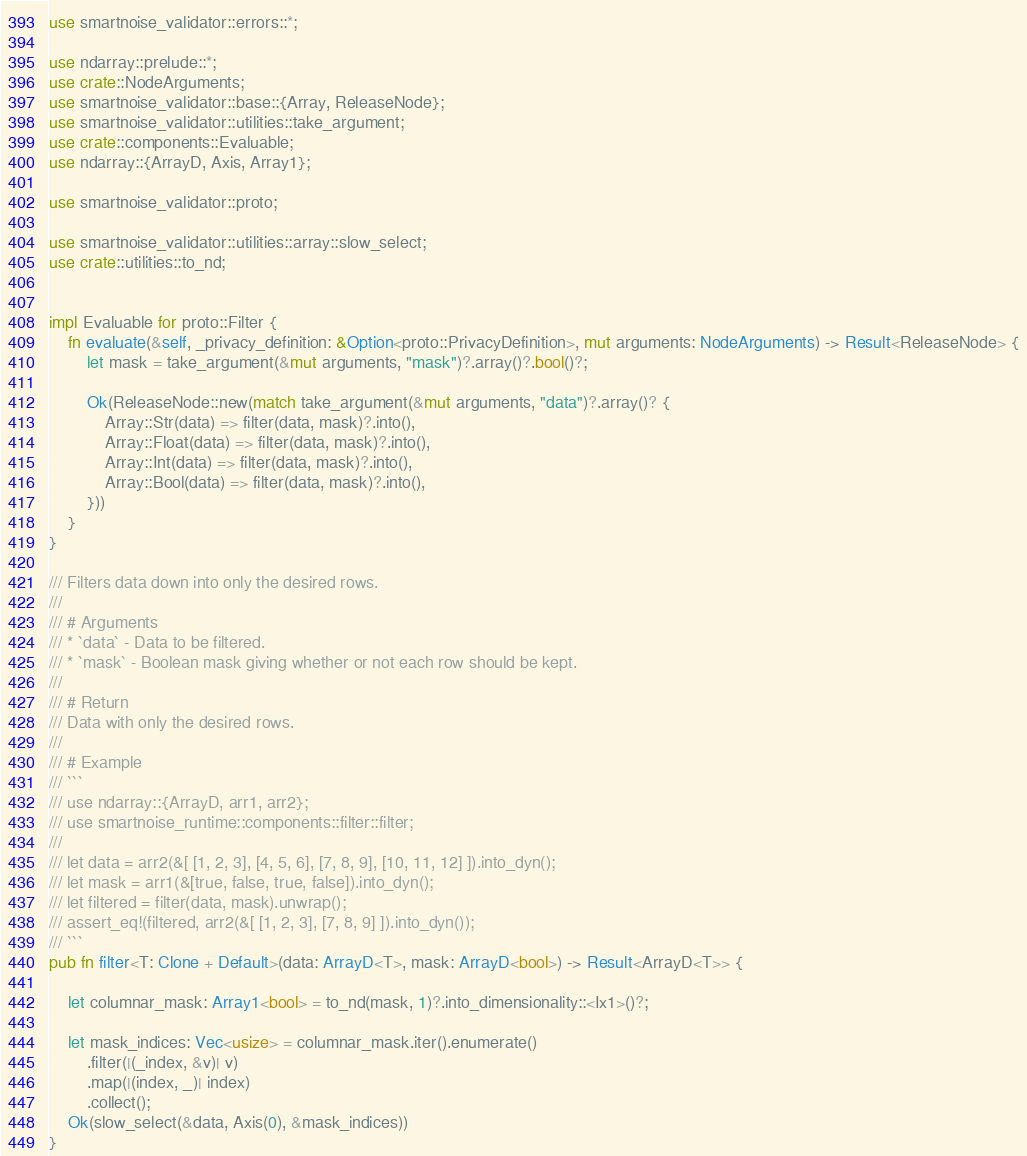Convert code to text. <code><loc_0><loc_0><loc_500><loc_500><_Rust_>use smartnoise_validator::errors::*;

use ndarray::prelude::*;
use crate::NodeArguments;
use smartnoise_validator::base::{Array, ReleaseNode};
use smartnoise_validator::utilities::take_argument;
use crate::components::Evaluable;
use ndarray::{ArrayD, Axis, Array1};

use smartnoise_validator::proto;

use smartnoise_validator::utilities::array::slow_select;
use crate::utilities::to_nd;


impl Evaluable for proto::Filter {
    fn evaluate(&self, _privacy_definition: &Option<proto::PrivacyDefinition>, mut arguments: NodeArguments) -> Result<ReleaseNode> {
        let mask = take_argument(&mut arguments, "mask")?.array()?.bool()?;

        Ok(ReleaseNode::new(match take_argument(&mut arguments, "data")?.array()? {
            Array::Str(data) => filter(data, mask)?.into(),
            Array::Float(data) => filter(data, mask)?.into(),
            Array::Int(data) => filter(data, mask)?.into(),
            Array::Bool(data) => filter(data, mask)?.into(),
        }))
    }
}

/// Filters data down into only the desired rows.
///
/// # Arguments
/// * `data` - Data to be filtered.
/// * `mask` - Boolean mask giving whether or not each row should be kept.
///
/// # Return
/// Data with only the desired rows.
///
/// # Example
/// ```
/// use ndarray::{ArrayD, arr1, arr2};
/// use smartnoise_runtime::components::filter::filter;
///
/// let data = arr2(&[ [1, 2, 3], [4, 5, 6], [7, 8, 9], [10, 11, 12] ]).into_dyn();
/// let mask = arr1(&[true, false, true, false]).into_dyn();
/// let filtered = filter(data, mask).unwrap();
/// assert_eq!(filtered, arr2(&[ [1, 2, 3], [7, 8, 9] ]).into_dyn());
/// ```
pub fn filter<T: Clone + Default>(data: ArrayD<T>, mask: ArrayD<bool>) -> Result<ArrayD<T>> {

    let columnar_mask: Array1<bool> = to_nd(mask, 1)?.into_dimensionality::<Ix1>()?;

    let mask_indices: Vec<usize> = columnar_mask.iter().enumerate()
        .filter(|(_index, &v)| v)
        .map(|(index, _)| index)
        .collect();
    Ok(slow_select(&data, Axis(0), &mask_indices))
}</code> 